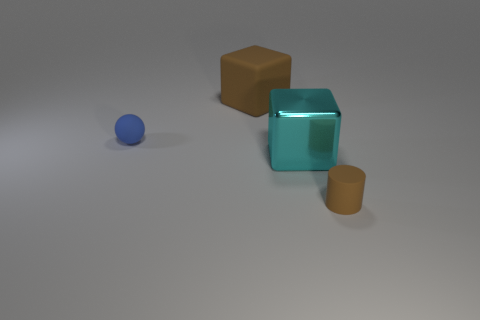There is a large object behind the blue object; what is its color?
Keep it short and to the point. Brown. How many things are either small rubber objects that are left of the tiny brown rubber cylinder or things that are on the right side of the blue ball?
Offer a terse response. 4. How many other cyan objects have the same shape as the cyan metal object?
Your response must be concise. 0. What color is the rubber cylinder that is the same size as the blue matte ball?
Provide a short and direct response. Brown. What is the color of the tiny object that is behind the small cylinder that is to the right of the big shiny block that is in front of the large brown matte cube?
Keep it short and to the point. Blue. There is a blue sphere; is it the same size as the brown matte thing in front of the big rubber block?
Ensure brevity in your answer.  Yes. What number of objects are either gray matte spheres or blocks?
Provide a succinct answer. 2. Are there any blue blocks that have the same material as the large cyan thing?
Give a very brief answer. No. What size is the rubber thing that is the same color as the cylinder?
Offer a terse response. Large. What color is the small object that is in front of the small rubber thing on the left side of the metal thing?
Provide a short and direct response. Brown. 